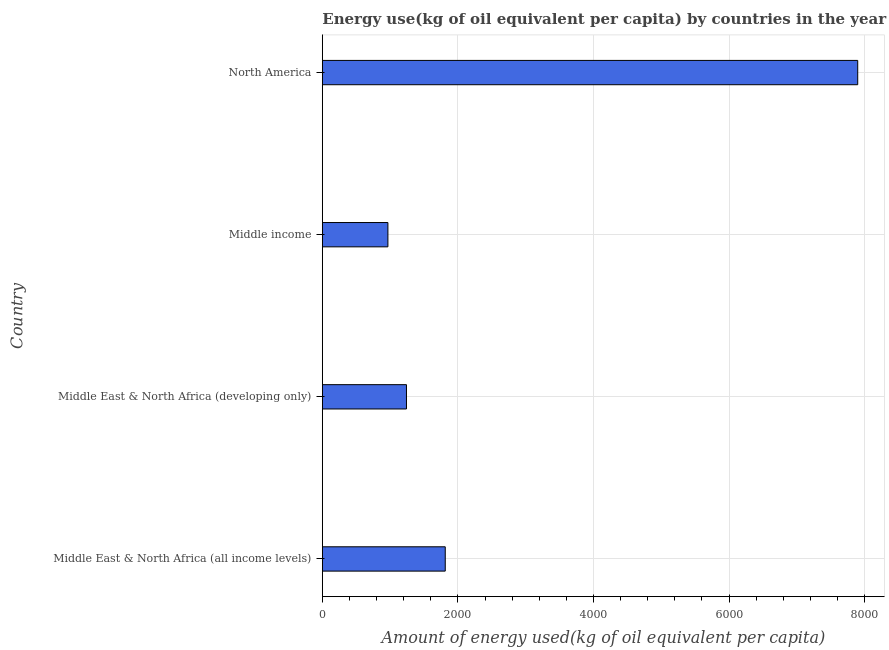What is the title of the graph?
Give a very brief answer. Energy use(kg of oil equivalent per capita) by countries in the year 2005. What is the label or title of the X-axis?
Offer a terse response. Amount of energy used(kg of oil equivalent per capita). What is the label or title of the Y-axis?
Your answer should be very brief. Country. What is the amount of energy used in North America?
Provide a succinct answer. 7898.97. Across all countries, what is the maximum amount of energy used?
Ensure brevity in your answer.  7898.97. Across all countries, what is the minimum amount of energy used?
Your answer should be compact. 967.58. In which country was the amount of energy used minimum?
Provide a short and direct response. Middle income. What is the sum of the amount of energy used?
Your answer should be very brief. 1.19e+04. What is the difference between the amount of energy used in Middle East & North Africa (all income levels) and Middle East & North Africa (developing only)?
Make the answer very short. 572.17. What is the average amount of energy used per country?
Make the answer very short. 2980.34. What is the median amount of energy used?
Make the answer very short. 1527.42. What is the ratio of the amount of energy used in Middle East & North Africa (developing only) to that in North America?
Keep it short and to the point. 0.16. Is the amount of energy used in Middle East & North Africa (developing only) less than that in North America?
Offer a very short reply. Yes. Is the difference between the amount of energy used in Middle East & North Africa (developing only) and North America greater than the difference between any two countries?
Your response must be concise. No. What is the difference between the highest and the second highest amount of energy used?
Your answer should be compact. 6085.46. Is the sum of the amount of energy used in Middle income and North America greater than the maximum amount of energy used across all countries?
Keep it short and to the point. Yes. What is the difference between the highest and the lowest amount of energy used?
Keep it short and to the point. 6931.39. In how many countries, is the amount of energy used greater than the average amount of energy used taken over all countries?
Your answer should be compact. 1. How many bars are there?
Keep it short and to the point. 4. Are all the bars in the graph horizontal?
Provide a short and direct response. Yes. How many countries are there in the graph?
Your answer should be compact. 4. Are the values on the major ticks of X-axis written in scientific E-notation?
Offer a very short reply. No. What is the Amount of energy used(kg of oil equivalent per capita) in Middle East & North Africa (all income levels)?
Make the answer very short. 1813.5. What is the Amount of energy used(kg of oil equivalent per capita) in Middle East & North Africa (developing only)?
Your response must be concise. 1241.33. What is the Amount of energy used(kg of oil equivalent per capita) of Middle income?
Provide a succinct answer. 967.58. What is the Amount of energy used(kg of oil equivalent per capita) of North America?
Make the answer very short. 7898.97. What is the difference between the Amount of energy used(kg of oil equivalent per capita) in Middle East & North Africa (all income levels) and Middle East & North Africa (developing only)?
Give a very brief answer. 572.18. What is the difference between the Amount of energy used(kg of oil equivalent per capita) in Middle East & North Africa (all income levels) and Middle income?
Ensure brevity in your answer.  845.93. What is the difference between the Amount of energy used(kg of oil equivalent per capita) in Middle East & North Africa (all income levels) and North America?
Your response must be concise. -6085.46. What is the difference between the Amount of energy used(kg of oil equivalent per capita) in Middle East & North Africa (developing only) and Middle income?
Provide a short and direct response. 273.75. What is the difference between the Amount of energy used(kg of oil equivalent per capita) in Middle East & North Africa (developing only) and North America?
Your answer should be very brief. -6657.64. What is the difference between the Amount of energy used(kg of oil equivalent per capita) in Middle income and North America?
Make the answer very short. -6931.39. What is the ratio of the Amount of energy used(kg of oil equivalent per capita) in Middle East & North Africa (all income levels) to that in Middle East & North Africa (developing only)?
Your answer should be compact. 1.46. What is the ratio of the Amount of energy used(kg of oil equivalent per capita) in Middle East & North Africa (all income levels) to that in Middle income?
Provide a short and direct response. 1.87. What is the ratio of the Amount of energy used(kg of oil equivalent per capita) in Middle East & North Africa (all income levels) to that in North America?
Ensure brevity in your answer.  0.23. What is the ratio of the Amount of energy used(kg of oil equivalent per capita) in Middle East & North Africa (developing only) to that in Middle income?
Offer a very short reply. 1.28. What is the ratio of the Amount of energy used(kg of oil equivalent per capita) in Middle East & North Africa (developing only) to that in North America?
Your answer should be compact. 0.16. What is the ratio of the Amount of energy used(kg of oil equivalent per capita) in Middle income to that in North America?
Provide a short and direct response. 0.12. 